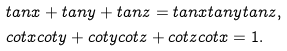<formula> <loc_0><loc_0><loc_500><loc_500>& t a n x + t a n y + t a n z = t a n x t a n y t a n z , \\ & c o t x c o t y + c o t y c o t z + c o t z c o t x = 1 .</formula> 